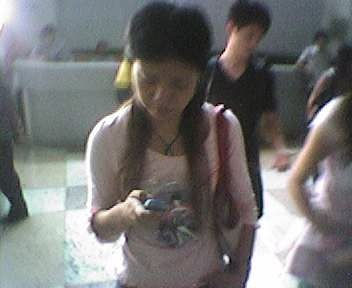Describe the objects in this image and their specific colors. I can see people in white, gray, and black tones, people in white, gray, lavender, darkgray, and black tones, people in white, black, and gray tones, people in white, gray, darkgray, black, and lavender tones, and handbag in white, gray, and black tones in this image. 